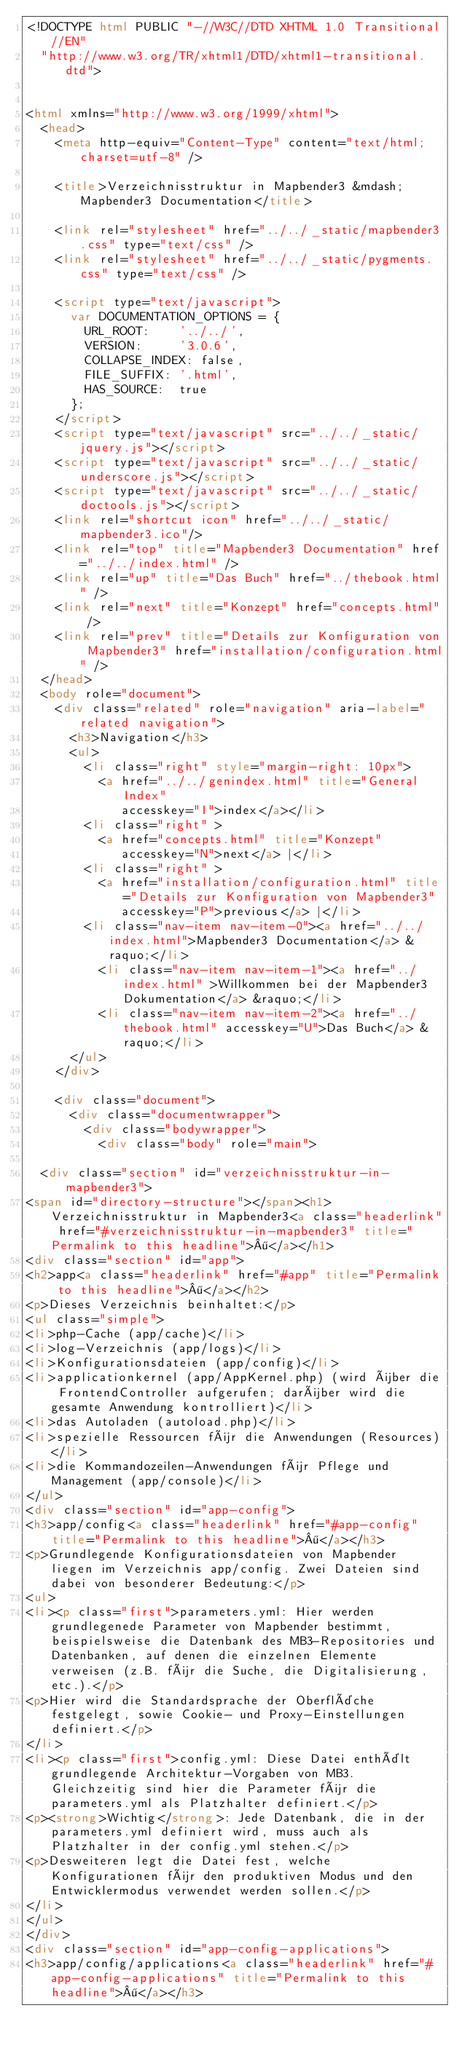<code> <loc_0><loc_0><loc_500><loc_500><_HTML_><!DOCTYPE html PUBLIC "-//W3C//DTD XHTML 1.0 Transitional//EN"
  "http://www.w3.org/TR/xhtml1/DTD/xhtml1-transitional.dtd">


<html xmlns="http://www.w3.org/1999/xhtml">
  <head>
    <meta http-equiv="Content-Type" content="text/html; charset=utf-8" />
    
    <title>Verzeichnisstruktur in Mapbender3 &mdash; Mapbender3 Documentation</title>
    
    <link rel="stylesheet" href="../../_static/mapbender3.css" type="text/css" />
    <link rel="stylesheet" href="../../_static/pygments.css" type="text/css" />
    
    <script type="text/javascript">
      var DOCUMENTATION_OPTIONS = {
        URL_ROOT:    '../../',
        VERSION:     '3.0.6',
        COLLAPSE_INDEX: false,
        FILE_SUFFIX: '.html',
        HAS_SOURCE:  true
      };
    </script>
    <script type="text/javascript" src="../../_static/jquery.js"></script>
    <script type="text/javascript" src="../../_static/underscore.js"></script>
    <script type="text/javascript" src="../../_static/doctools.js"></script>
    <link rel="shortcut icon" href="../../_static/mapbender3.ico"/>
    <link rel="top" title="Mapbender3 Documentation" href="../../index.html" />
    <link rel="up" title="Das Buch" href="../thebook.html" />
    <link rel="next" title="Konzept" href="concepts.html" />
    <link rel="prev" title="Details zur Konfiguration von Mapbender3" href="installation/configuration.html" /> 
  </head>
  <body role="document">
    <div class="related" role="navigation" aria-label="related navigation">
      <h3>Navigation</h3>
      <ul>
        <li class="right" style="margin-right: 10px">
          <a href="../../genindex.html" title="General Index"
             accesskey="I">index</a></li>
        <li class="right" >
          <a href="concepts.html" title="Konzept"
             accesskey="N">next</a> |</li>
        <li class="right" >
          <a href="installation/configuration.html" title="Details zur Konfiguration von Mapbender3"
             accesskey="P">previous</a> |</li>
        <li class="nav-item nav-item-0"><a href="../../index.html">Mapbender3 Documentation</a> &raquo;</li>
          <li class="nav-item nav-item-1"><a href="../index.html" >Willkommen bei der Mapbender3 Dokumentation</a> &raquo;</li>
          <li class="nav-item nav-item-2"><a href="../thebook.html" accesskey="U">Das Buch</a> &raquo;</li> 
      </ul>
    </div>  

    <div class="document">
      <div class="documentwrapper">
        <div class="bodywrapper">
          <div class="body" role="main">
            
  <div class="section" id="verzeichnisstruktur-in-mapbender3">
<span id="directory-structure"></span><h1>Verzeichnisstruktur in Mapbender3<a class="headerlink" href="#verzeichnisstruktur-in-mapbender3" title="Permalink to this headline">¶</a></h1>
<div class="section" id="app">
<h2>app<a class="headerlink" href="#app" title="Permalink to this headline">¶</a></h2>
<p>Dieses Verzeichnis beinhaltet:</p>
<ul class="simple">
<li>php-Cache (app/cache)</li>
<li>log-Verzeichnis (app/logs)</li>
<li>Konfigurationsdateien (app/config)</li>
<li>applicationkernel (app/AppKernel.php) (wird über die FrontendController aufgerufen; darüber wird die gesamte Anwendung kontrolliert)</li>
<li>das Autoladen (autoload.php)</li>
<li>spezielle Ressourcen für die Anwendungen (Resources)</li>
<li>die Kommandozeilen-Anwendungen für Pflege und Management (app/console)</li>
</ul>
<div class="section" id="app-config">
<h3>app/config<a class="headerlink" href="#app-config" title="Permalink to this headline">¶</a></h3>
<p>Grundlegende Konfigurationsdateien von Mapbender liegen im Verzeichnis app/config. Zwei Dateien sind dabei von besonderer Bedeutung:</p>
<ul>
<li><p class="first">parameters.yml: Hier werden grundlegenede Parameter von Mapbender bestimmt, beispielsweise die Datenbank des MB3-Repositories und Datenbanken, auf denen die einzelnen Elemente verweisen (z.B. für die Suche, die Digitalisierung, etc.).</p>
<p>Hier wird die Standardsprache der Oberfläche festgelegt, sowie Cookie- und Proxy-Einstellungen definiert.</p>
</li>
<li><p class="first">config.yml: Diese Datei enthält grundlegende Architektur-Vorgaben von MB3. Gleichzeitig sind hier die Parameter für die parameters.yml als Platzhalter definiert.</p>
<p><strong>Wichtig</strong>: Jede Datenbank, die in der parameters.yml definiert wird, muss auch als Platzhalter in der config.yml stehen.</p>
<p>Desweiteren legt die Datei fest, welche Konfigurationen für den produktiven Modus und den Entwicklermodus verwendet werden sollen.</p>
</li>
</ul>
</div>
<div class="section" id="app-config-applications">
<h3>app/config/applications<a class="headerlink" href="#app-config-applications" title="Permalink to this headline">¶</a></h3></code> 